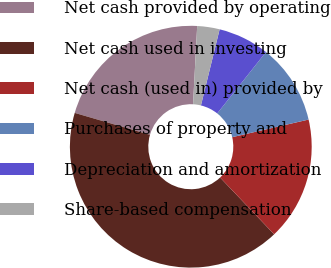<chart> <loc_0><loc_0><loc_500><loc_500><pie_chart><fcel>Net cash provided by operating<fcel>Net cash used in investing<fcel>Net cash (used in) provided by<fcel>Purchases of property and<fcel>Depreciation and amortization<fcel>Share-based compensation<nl><fcel>21.33%<fcel>41.62%<fcel>16.5%<fcel>10.71%<fcel>6.85%<fcel>2.99%<nl></chart> 